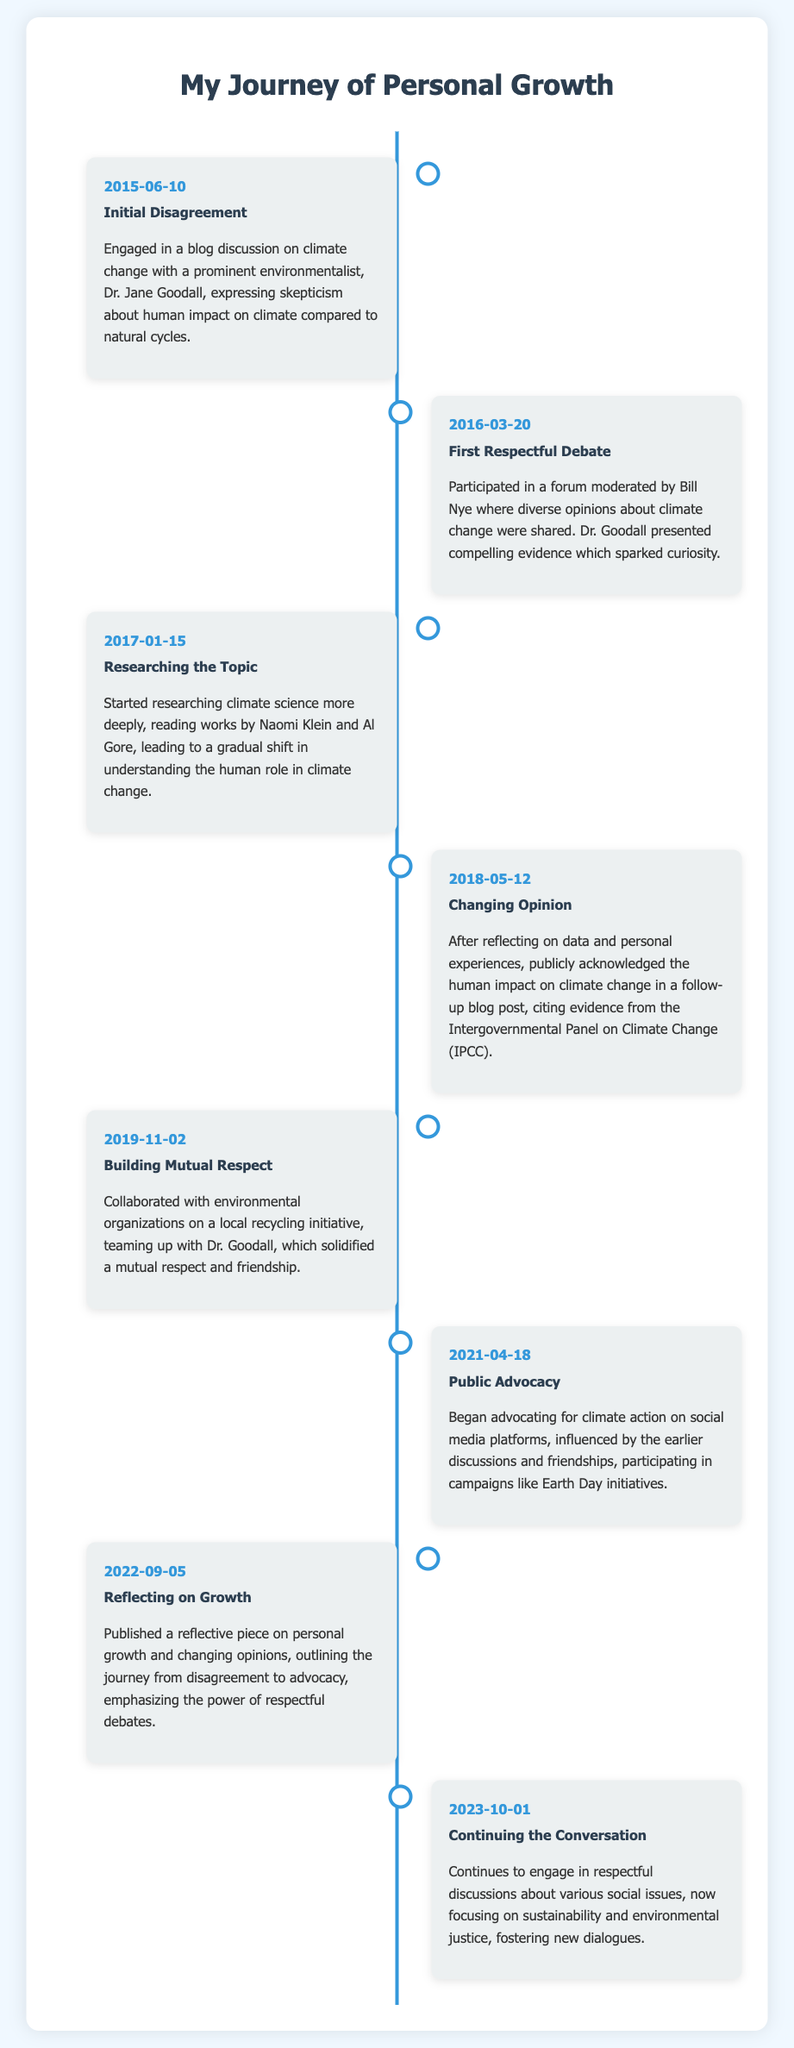what date did the initial disagreement occur? The initial disagreement is recorded on the date of the first entry in the timeline.
Answer: 2015-06-10 who was the prominent environmentalist mentioned? The prominent environmentalist discussed in the initial disagreement was engaged in a blog discussion.
Answer: Dr. Jane Goodall what major change occurred in 2018? The significant change involved the acknowledgment of human impact on climate change published in a follow-up blog post.
Answer: Changing Opinion how many years passed from the initial disagreement to the public advocacy? This is calculated by finding the difference between the two dates on the timeline entries.
Answer: 6 which campaign did the individual participate in during their public advocacy? This refers to a specific initiative the individual engaged in as a part of their advocacy efforts.
Answer: Earth Day initiatives what was the main topic of reflection published in 2022? This question focuses on the theme of the reflective piece published that year regarding personal growth.
Answer: Reflecting on Growth which individual influenced the shift in opinion according to the timeline? Referring to the impactful figure mentioned throughout the timeline that contributed to the growth process.
Answer: Dr. Jane Goodall what is the focus of the discussions as of 2023? The focus of the individual's discussions can be found in the final entry of the timeline.
Answer: sustainability and environmental justice 